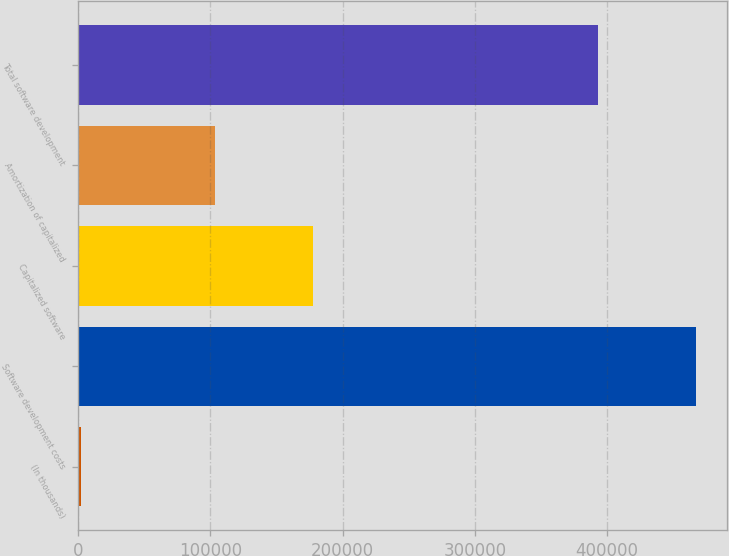<chart> <loc_0><loc_0><loc_500><loc_500><bar_chart><fcel>(In thousands)<fcel>Software development costs<fcel>Capitalized software<fcel>Amortization of capitalized<fcel>Total software development<nl><fcel>2014<fcel>467158<fcel>177800<fcel>103447<fcel>392805<nl></chart> 